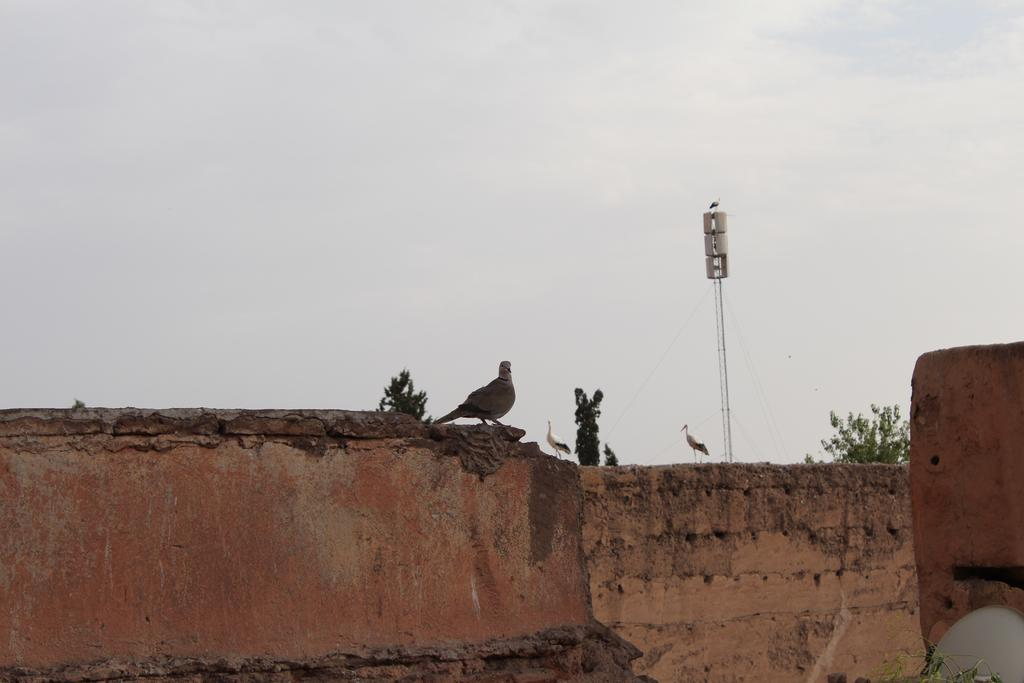What type of animals can be seen on the wall in the image? There are birds on the wall in the image. What type of vegetation is present in the image? There are trees in the image. What is the tall, vertical object in the image? There is a pole in the image. What can be seen in the background of the image? The sky is visible in the background of the image. How many pets does the person in the image own? There is no person present in the image, and therefore no pets can be associated with the image. What type of van is parked near the trees in the image? There is no van present in the image; it only features birds, trees, a pole, and the sky. 